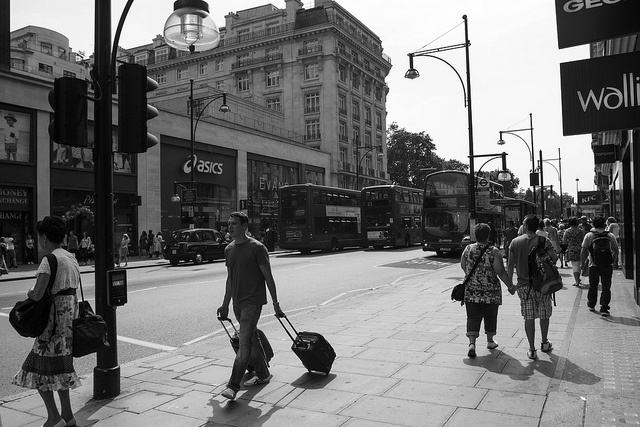Describe the objects in this image and their specific colors. I can see people in black, gray, darkgray, and lightgray tones, people in black, gray, darkgray, and lightgray tones, bus in black, gray, darkgray, and lightgray tones, bus in black and gray tones, and bus in black, gray, and lightgray tones in this image. 